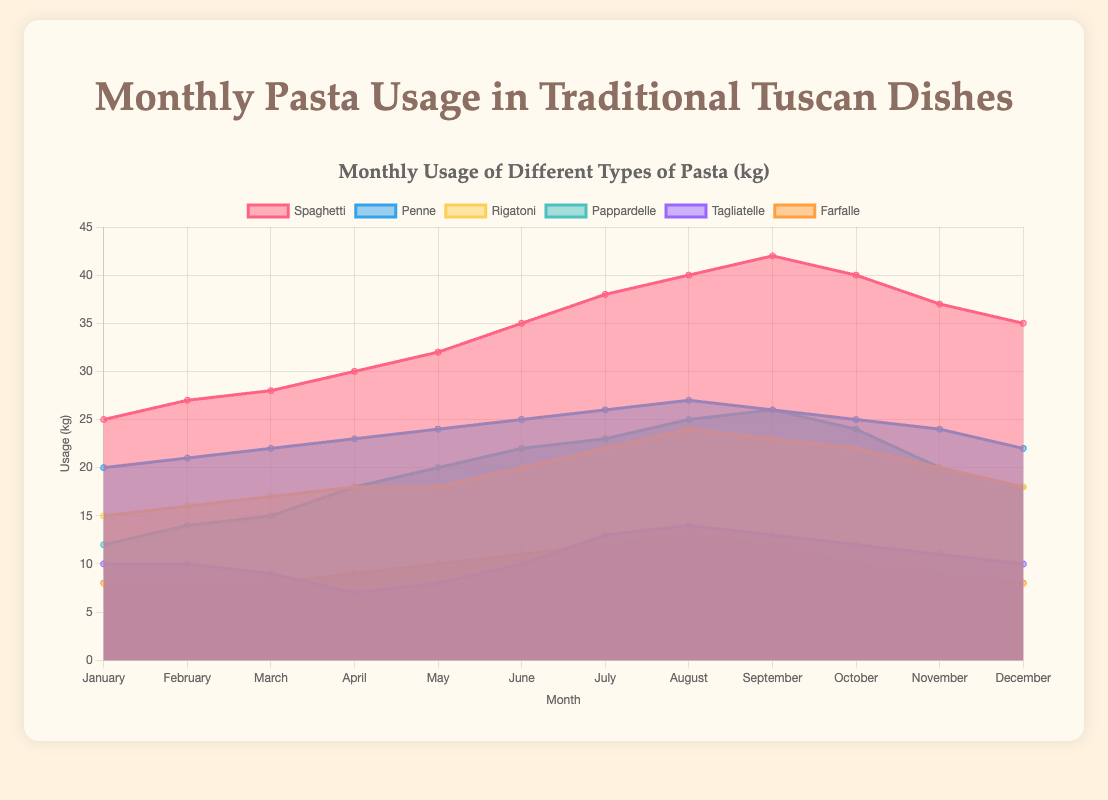What is the title of the figure? The title of the figure can be found at the top of the chart. It provides an overview of the data presented.
Answer: Monthly Usage of Different Types of Pasta (kg) Which type of pasta has the highest usage in July? To find the highest usage in July, look at the values for each type of pasta on the y-axis corresponding to July. Identify the pasta type with the greatest value.
Answer: Spaghetti In which month is the usage of Penne the highest? To determine the month with the highest usage of Penne, observe the Penne data points and find the peak value's corresponding month on the x-axis.
Answer: August How does the usage of Tagliatelle in February compare to its usage in April? Locate the data points for Tagliatelle in February and April. Compare the values to see which is higher.
Answer: Higher in February What is the total usage of Pappardelle and Spaghetti in December? Sum the December values for Pappardelle and Spaghetti from their respective data points.
Answer: 18 + 35 = 53 kg How much more Spaghetti is used in June compared to January? Find the usage values for Spaghetti in June and January, then subtract January's value from June's value.
Answer: 35 - 25 = 10 kg Identify the type of pasta with the smallest variation in monthly usage throughout the year. Look at the range of data values for each type of pasta and identify the one with the least difference between its highest and lowest values.
Answer: Farfalle What is the average monthly usage of Rigatoni? Sum the monthly values for Rigatoni and divide by the number of months to find the average. (15+16+17+18+18+20+22+24+23+22+20+18) / 12
Answer: 19.08 kg Which two types of pasta have the closest usage values in May? Compare the usage values for all pasta types in May and find the two types with the closest values.
Answer: Rigatoni and Pappardelle Does the total pasta usage increase or decrease from January to June? Sum the usage values for all pasta types in January and June, then compare the totals to determine the trend.
Answer: Increase 